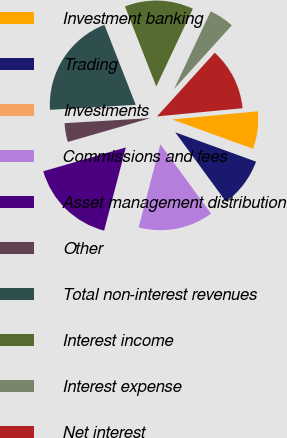Convert chart to OTSL. <chart><loc_0><loc_0><loc_500><loc_500><pie_chart><fcel>Investment banking<fcel>Trading<fcel>Investments<fcel>Commissions and fees<fcel>Asset management distribution<fcel>Other<fcel>Total non-interest revenues<fcel>Interest income<fcel>Interest expense<fcel>Net interest<nl><fcel>7.06%<fcel>9.41%<fcel>0.01%<fcel>14.11%<fcel>16.46%<fcel>3.54%<fcel>19.99%<fcel>12.94%<fcel>4.71%<fcel>11.76%<nl></chart> 